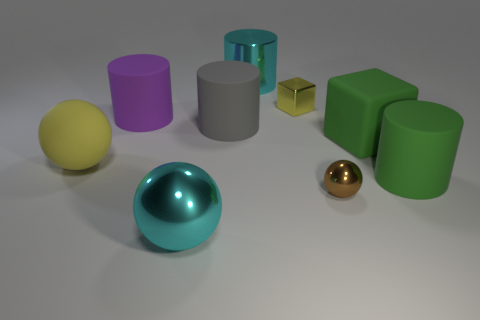Is there a pattern to the arrangement of the objects? The objects seem to be arranged in a random pattern across the surface. There does not appear to be any intentional sequencing or progression in size, shape, or color.  Could you describe the lighting in the scene? Certainly, the lighting appears soft and diffused, with shadows cast to the side of the objects, suggesting a light source above and to the left of the scene. This creates a gentle contrast across the various geometric shapes. 